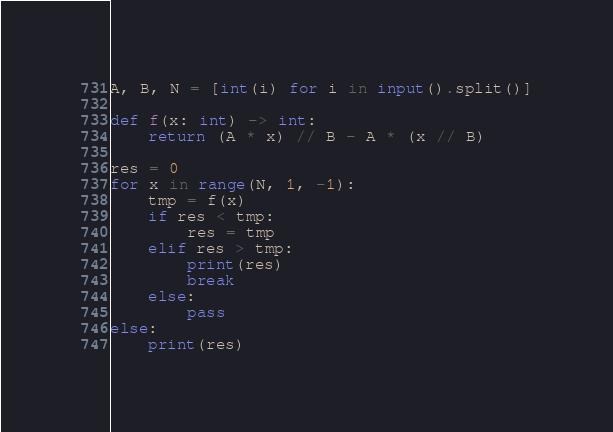<code> <loc_0><loc_0><loc_500><loc_500><_Python_>A, B, N = [int(i) for i in input().split()]

def f(x: int) -> int:
    return (A * x) // B - A * (x // B)

res = 0
for x in range(N, 1, -1):
    tmp = f(x)
    if res < tmp:
        res = tmp
    elif res > tmp:
        print(res)
        break
    else:
        pass
else:
    print(res)
</code> 